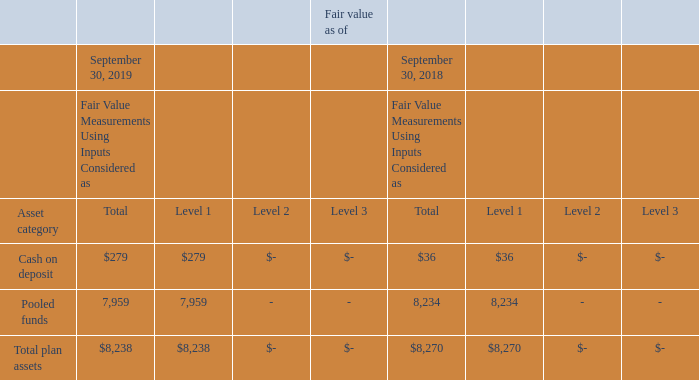The fair value of the assets held by the U.K. pension plan by asset category are as follows:
The expected long-term rates of return on plan assets are equal to the yields to maturity of appropriate indices for government and corporate bonds and by adding a premium to the government bond return for equities. The expected rate of return on cash is the Bank of England base rate in force at the effective date.
Level 1 investments represent mutual funds for which a quoted market price is available on an active market. These investments primarily hold stocks or bonds, or a combination of stocks and bonds.
What do Level 1 investments represent? Mutual funds for which a quoted market price is available on an active market. What is the expected rate of return on cash? The bank of england base rate in force at the effective date. How is the expected long-term rates of return on plan assets determined? Adding a premium to the government bond return for equities. What is the difference in the Level 2 and 3 cash on deposit as of September 2019?
Answer scale should be: thousand. 0 - 0 
Answer: 0. What is the the value of the 2019 cash on deposit as a percentage of the total 2019 plan assets? 
Answer scale should be: percent. 279/8,238 
Answer: 3.39. What is the percentage change in the total plan assets between 2018 and 2019?
Answer scale should be: percent. ($8,238 - $8,270)/ $8,270 
Answer: -0.39. 